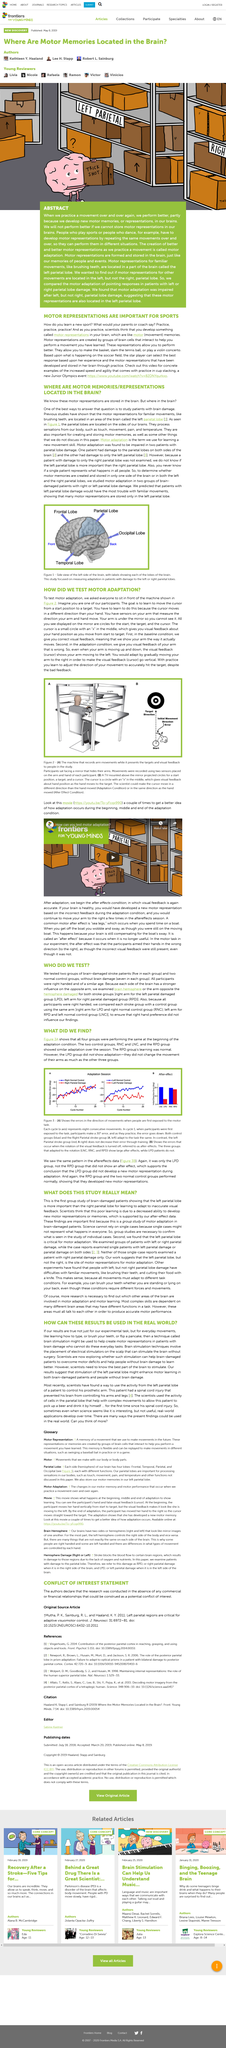Specify some key components in this picture. The four lobes of the brain are the frontal, temporal, parietal, and occipital lobes. What are motor representations like? They are like motor memories of movement. Developing effective moot presentations requires practicing a task repeatedly to improve proficiency. Motor representations, also known as memories, are alternative names for the mental representations of actions and movements that are used for planning, executing, and learning new skills. A total of 24 participants were tested in total. 